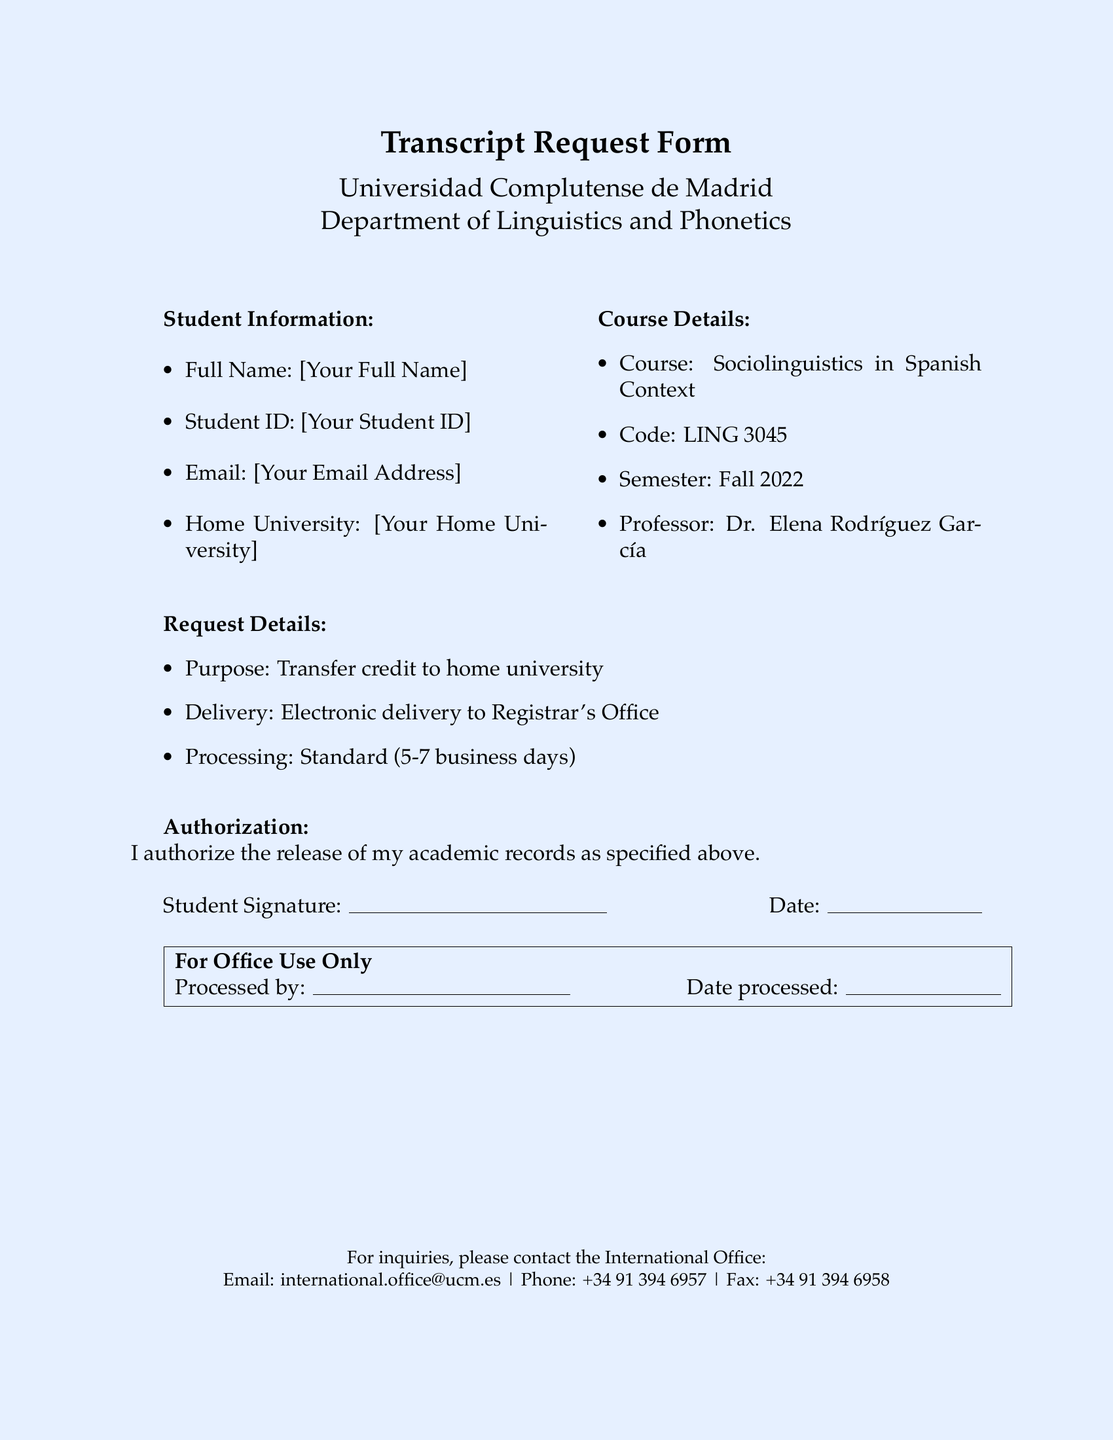What is the name of the university? The name of the university is provided in the header of the document.
Answer: Universidad Complutense de Madrid What is the course title? The course title is listed under Course Details and identifies the subject being studied.
Answer: Sociolinguistics in Spanish Context Who is the professor for the course? The professor's name can be found in the Course Details section.
Answer: Dr. Elena Rodríguez García What is the processing time for the request? The processing time is detailed under Request Details, indicating how long it will take to process the request.
Answer: 5-7 business days What is the purpose of the transcript request? The purpose of the request is mentioned explicitly in the Request Details section.
Answer: Transfer credit to home university What information is required in the Student Information section? The required information can be found listed in the Student Information section of the document.
Answer: Full Name, Student ID, Email, Home University What type of delivery is specified for the transcripts? The type of delivery method can be found in the Request Details section, indicating how the requester wants the documents sent.
Answer: Electronic delivery to Registrar's Office What is the fax number for inquiries? The fax number is provided at the bottom of the document in the contact information for the International Office.
Answer: +34 91 394 6958 